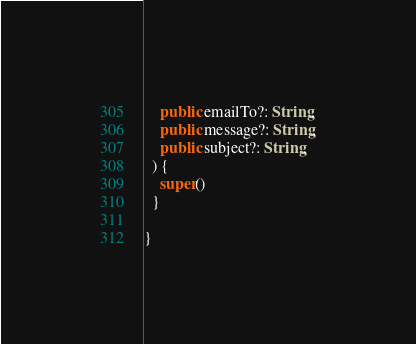Convert code to text. <code><loc_0><loc_0><loc_500><loc_500><_TypeScript_>    public emailTo?: String,
    public message?: String,
    public subject?: String,
  ) {
    super()
  }

}
</code> 